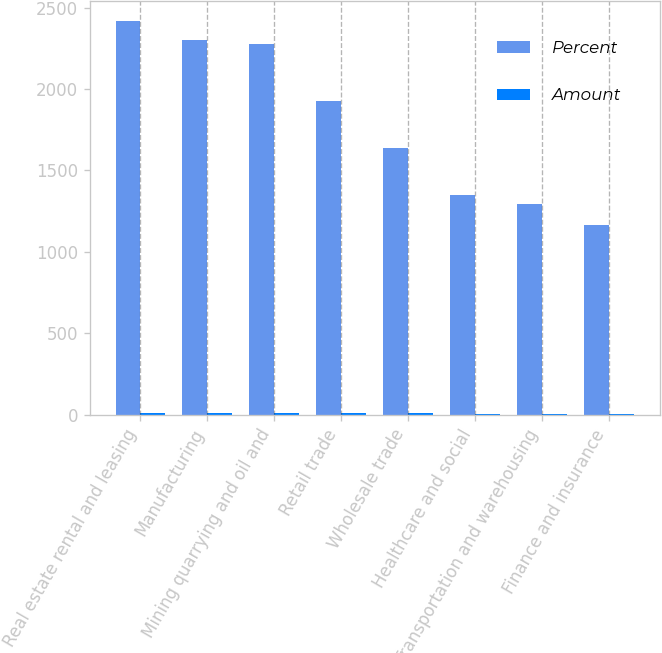Convert chart to OTSL. <chart><loc_0><loc_0><loc_500><loc_500><stacked_bar_chart><ecel><fcel>Real estate rental and leasing<fcel>Manufacturing<fcel>Mining quarrying and oil and<fcel>Retail trade<fcel>Wholesale trade<fcel>Healthcare and social<fcel>Transportation and warehousing<fcel>Finance and insurance<nl><fcel>Percent<fcel>2418<fcel>2305<fcel>2277<fcel>1924<fcel>1638<fcel>1347<fcel>1294<fcel>1168<nl><fcel>Amount<fcel>11.4<fcel>10.7<fcel>10.6<fcel>9<fcel>7.6<fcel>6.3<fcel>6<fcel>5.5<nl></chart> 